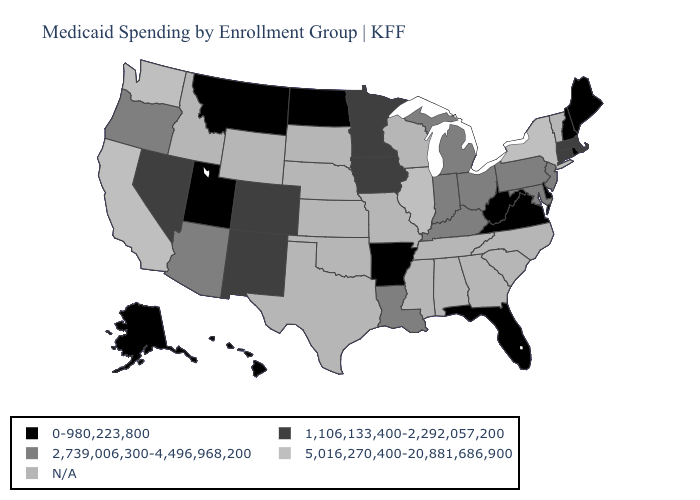What is the value of Wisconsin?
Answer briefly. N/A. What is the value of North Dakota?
Be succinct. 0-980,223,800. Does New York have the highest value in the Northeast?
Give a very brief answer. Yes. How many symbols are there in the legend?
Keep it brief. 5. Does the first symbol in the legend represent the smallest category?
Write a very short answer. Yes. Name the states that have a value in the range 2,739,006,300-4,496,968,200?
Be succinct. Arizona, Indiana, Kentucky, Louisiana, Maryland, Michigan, New Jersey, Ohio, Oregon, Pennsylvania. How many symbols are there in the legend?
Keep it brief. 5. Does Oregon have the lowest value in the West?
Short answer required. No. Name the states that have a value in the range 5,016,270,400-20,881,686,900?
Keep it brief. California, Illinois, New York, Washington. What is the value of West Virginia?
Give a very brief answer. 0-980,223,800. Name the states that have a value in the range 5,016,270,400-20,881,686,900?
Short answer required. California, Illinois, New York, Washington. Is the legend a continuous bar?
Write a very short answer. No. 